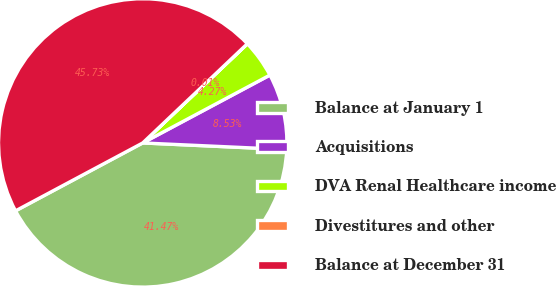Convert chart to OTSL. <chart><loc_0><loc_0><loc_500><loc_500><pie_chart><fcel>Balance at January 1<fcel>Acquisitions<fcel>DVA Renal Healthcare income<fcel>Divestitures and other<fcel>Balance at December 31<nl><fcel>41.47%<fcel>8.53%<fcel>4.27%<fcel>0.01%<fcel>45.73%<nl></chart> 